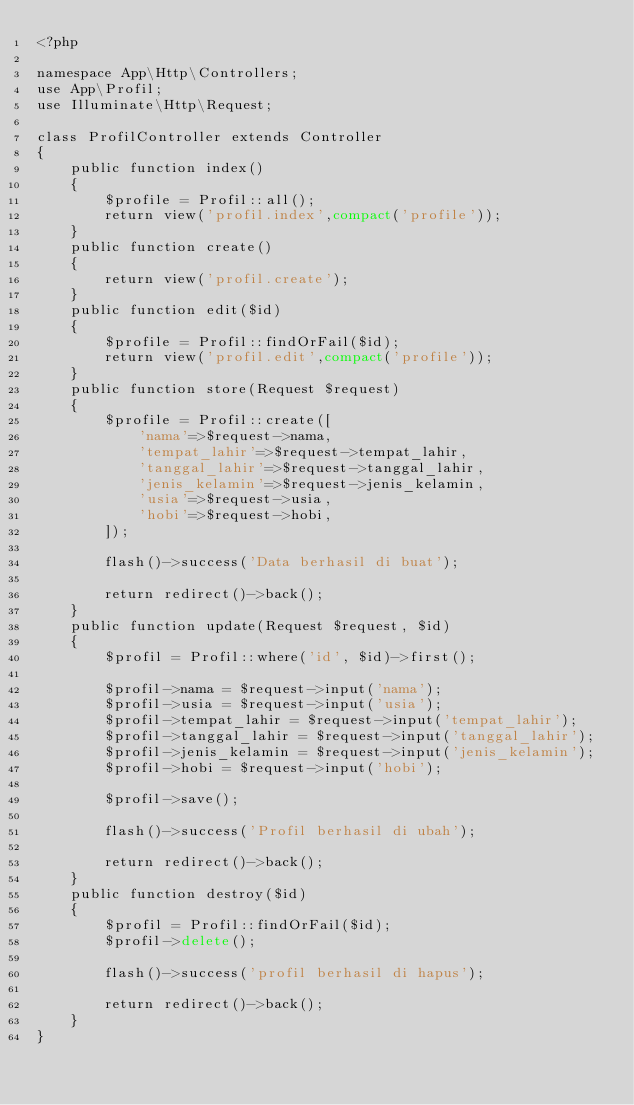Convert code to text. <code><loc_0><loc_0><loc_500><loc_500><_PHP_><?php

namespace App\Http\Controllers;
use App\Profil;
use Illuminate\Http\Request;

class ProfilController extends Controller
{
    public function index()
    {
        $profile = Profil::all();
        return view('profil.index',compact('profile'));
    }
    public function create()
    {
        return view('profil.create');
    }
    public function edit($id)
    {
        $profile = Profil::findOrFail($id);
        return view('profil.edit',compact('profile'));
    }
    public function store(Request $request)
    {
        $profile = Profil::create([
            'nama'=>$request->nama,
            'tempat_lahir'=>$request->tempat_lahir,
            'tanggal_lahir'=>$request->tanggal_lahir,
            'jenis_kelamin'=>$request->jenis_kelamin,
            'usia'=>$request->usia,
            'hobi'=>$request->hobi,
        ]);

        flash()->success('Data berhasil di buat');

        return redirect()->back();
    }
    public function update(Request $request, $id)
    {
        $profil = Profil::where('id', $id)->first();

        $profil->nama = $request->input('nama');
        $profil->usia = $request->input('usia');
        $profil->tempat_lahir = $request->input('tempat_lahir');
        $profil->tanggal_lahir = $request->input('tanggal_lahir');
        $profil->jenis_kelamin = $request->input('jenis_kelamin');
        $profil->hobi = $request->input('hobi');

        $profil->save();

        flash()->success('Profil berhasil di ubah');

        return redirect()->back();
    }
    public function destroy($id)
    {
        $profil = Profil::findOrFail($id);
        $profil->delete();

        flash()->success('profil berhasil di hapus');

        return redirect()->back();
    }
}
</code> 